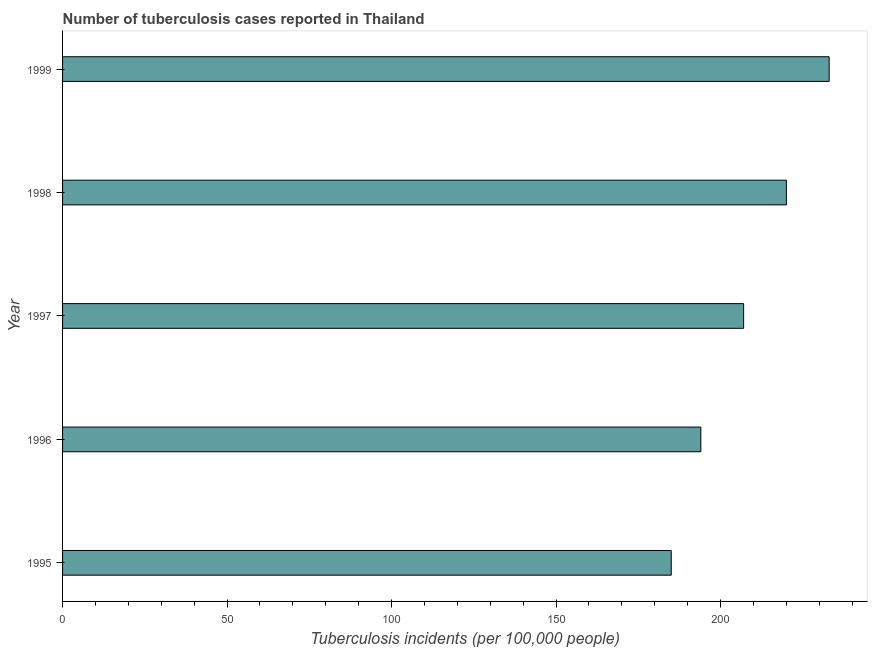Does the graph contain grids?
Provide a succinct answer. No. What is the title of the graph?
Your answer should be very brief. Number of tuberculosis cases reported in Thailand. What is the label or title of the X-axis?
Give a very brief answer. Tuberculosis incidents (per 100,0 people). What is the number of tuberculosis incidents in 1998?
Give a very brief answer. 220. Across all years, what is the maximum number of tuberculosis incidents?
Offer a very short reply. 233. Across all years, what is the minimum number of tuberculosis incidents?
Ensure brevity in your answer.  185. In which year was the number of tuberculosis incidents maximum?
Provide a short and direct response. 1999. In which year was the number of tuberculosis incidents minimum?
Keep it short and to the point. 1995. What is the sum of the number of tuberculosis incidents?
Give a very brief answer. 1039. What is the difference between the number of tuberculosis incidents in 1996 and 1999?
Offer a very short reply. -39. What is the average number of tuberculosis incidents per year?
Give a very brief answer. 207. What is the median number of tuberculosis incidents?
Ensure brevity in your answer.  207. What is the ratio of the number of tuberculosis incidents in 1997 to that in 1999?
Provide a succinct answer. 0.89. Is the number of tuberculosis incidents in 1998 less than that in 1999?
Make the answer very short. Yes. What is the difference between the highest and the second highest number of tuberculosis incidents?
Your response must be concise. 13. How many bars are there?
Your response must be concise. 5. What is the difference between two consecutive major ticks on the X-axis?
Provide a succinct answer. 50. What is the Tuberculosis incidents (per 100,000 people) in 1995?
Your answer should be compact. 185. What is the Tuberculosis incidents (per 100,000 people) of 1996?
Provide a short and direct response. 194. What is the Tuberculosis incidents (per 100,000 people) in 1997?
Offer a terse response. 207. What is the Tuberculosis incidents (per 100,000 people) of 1998?
Your answer should be compact. 220. What is the Tuberculosis incidents (per 100,000 people) in 1999?
Provide a short and direct response. 233. What is the difference between the Tuberculosis incidents (per 100,000 people) in 1995 and 1996?
Offer a very short reply. -9. What is the difference between the Tuberculosis incidents (per 100,000 people) in 1995 and 1997?
Keep it short and to the point. -22. What is the difference between the Tuberculosis incidents (per 100,000 people) in 1995 and 1998?
Your response must be concise. -35. What is the difference between the Tuberculosis incidents (per 100,000 people) in 1995 and 1999?
Your response must be concise. -48. What is the difference between the Tuberculosis incidents (per 100,000 people) in 1996 and 1997?
Your answer should be very brief. -13. What is the difference between the Tuberculosis incidents (per 100,000 people) in 1996 and 1998?
Provide a short and direct response. -26. What is the difference between the Tuberculosis incidents (per 100,000 people) in 1996 and 1999?
Your response must be concise. -39. What is the difference between the Tuberculosis incidents (per 100,000 people) in 1997 and 1999?
Give a very brief answer. -26. What is the ratio of the Tuberculosis incidents (per 100,000 people) in 1995 to that in 1996?
Provide a short and direct response. 0.95. What is the ratio of the Tuberculosis incidents (per 100,000 people) in 1995 to that in 1997?
Provide a succinct answer. 0.89. What is the ratio of the Tuberculosis incidents (per 100,000 people) in 1995 to that in 1998?
Your answer should be compact. 0.84. What is the ratio of the Tuberculosis incidents (per 100,000 people) in 1995 to that in 1999?
Offer a terse response. 0.79. What is the ratio of the Tuberculosis incidents (per 100,000 people) in 1996 to that in 1997?
Offer a terse response. 0.94. What is the ratio of the Tuberculosis incidents (per 100,000 people) in 1996 to that in 1998?
Offer a terse response. 0.88. What is the ratio of the Tuberculosis incidents (per 100,000 people) in 1996 to that in 1999?
Ensure brevity in your answer.  0.83. What is the ratio of the Tuberculosis incidents (per 100,000 people) in 1997 to that in 1998?
Keep it short and to the point. 0.94. What is the ratio of the Tuberculosis incidents (per 100,000 people) in 1997 to that in 1999?
Ensure brevity in your answer.  0.89. What is the ratio of the Tuberculosis incidents (per 100,000 people) in 1998 to that in 1999?
Provide a short and direct response. 0.94. 